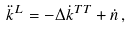Convert formula to latex. <formula><loc_0><loc_0><loc_500><loc_500>\ddot { k } ^ { L } = - \Delta \dot { k } ^ { T T } + \dot { n } \, ,</formula> 